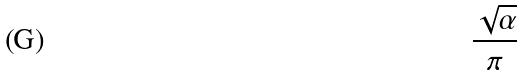Convert formula to latex. <formula><loc_0><loc_0><loc_500><loc_500>\frac { \sqrt { \alpha } } { \pi }</formula> 